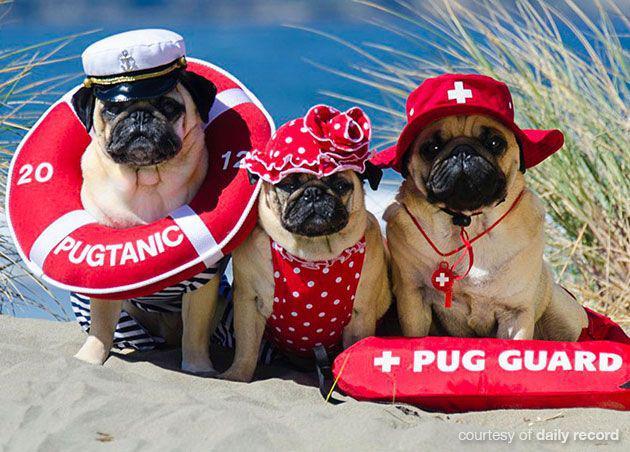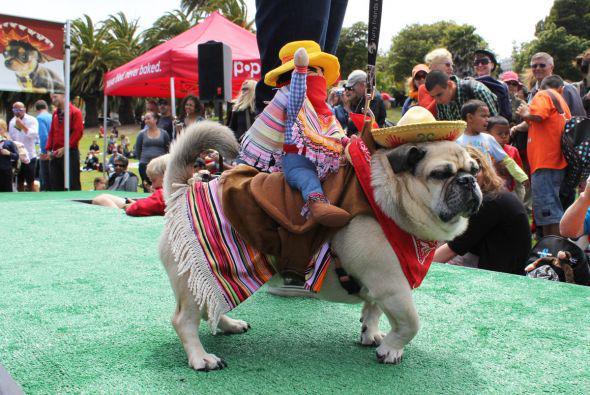The first image is the image on the left, the second image is the image on the right. For the images displayed, is the sentence "An image shows two costumed pug dogs inside a container." factually correct? Answer yes or no. No. The first image is the image on the left, the second image is the image on the right. Examine the images to the left and right. Is the description "In one image, there are two pugs in a container that has a paper on it with printed text." accurate? Answer yes or no. No. 